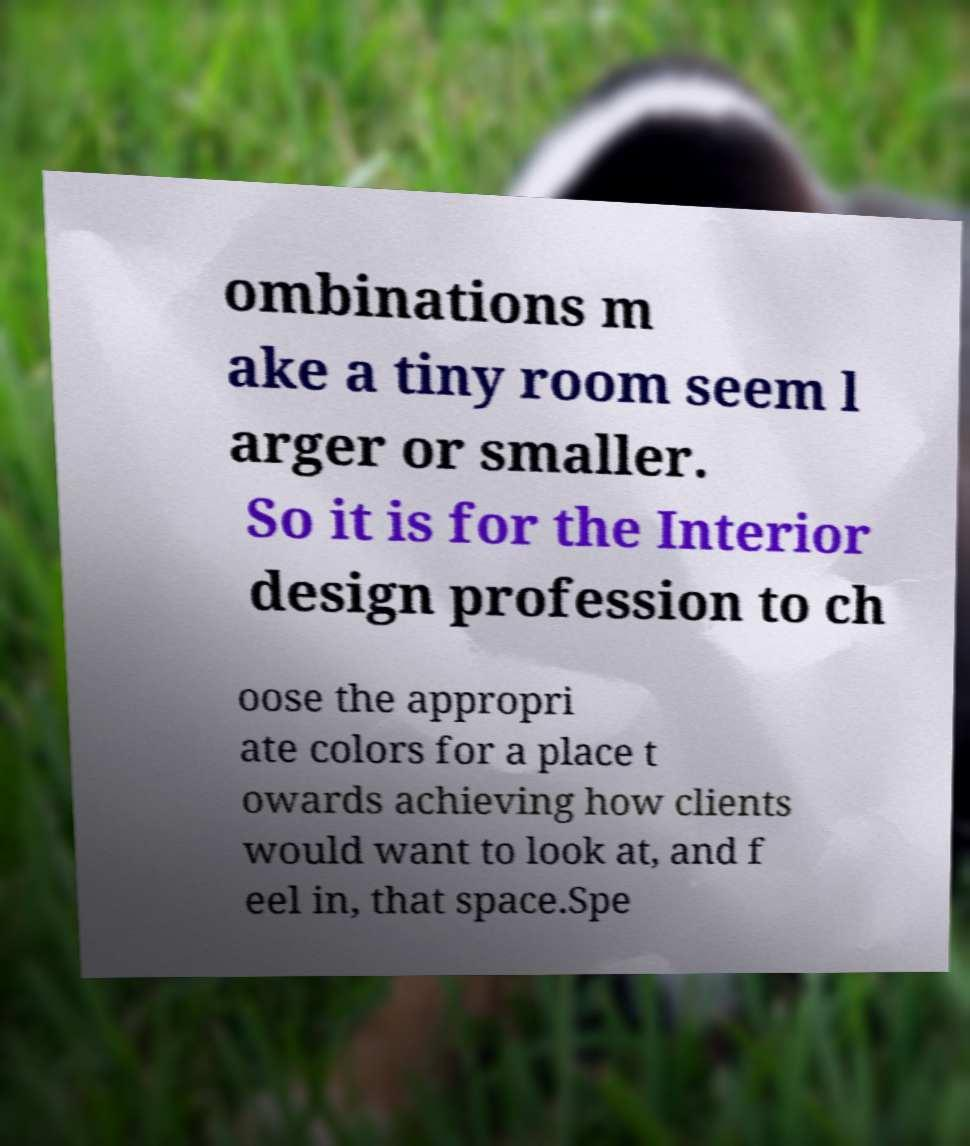Please read and relay the text visible in this image. What does it say? ombinations m ake a tiny room seem l arger or smaller. So it is for the Interior design profession to ch oose the appropri ate colors for a place t owards achieving how clients would want to look at, and f eel in, that space.Spe 